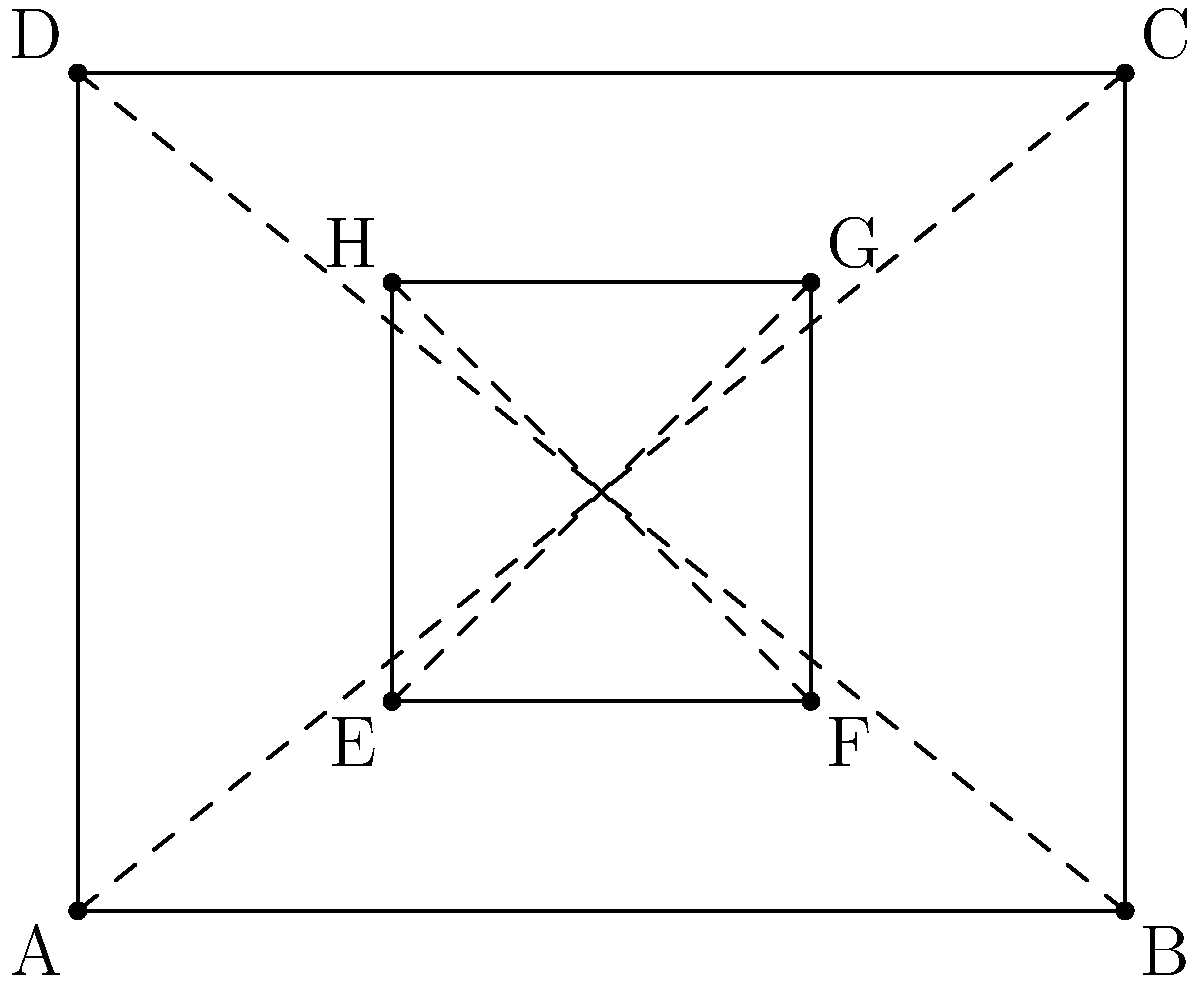In this simple architectural sketch of a room with a window, which perspective technique is being demonstrated by the dashed lines connecting opposite corners? To answer this question, let's analyze the sketch step-by-step:

1. The outer rectangle (ABCD) represents the room's walls.
2. The inner rectangle (EFGH) represents the window.
3. There are dashed lines connecting opposite corners of both the room and the window.

These dashed lines are demonstrating a fundamental principle in perspective drawing:

4. The lines AC and BD intersect at a point that would be on the horizon line (not shown in this sketch).
5. Similarly, the lines EG and FH also intersect at a point on the same horizon line.
6. This point of intersection is known as the vanishing point.

The technique being demonstrated here is one-point perspective. In one-point perspective:

7. All lines that are perpendicular to the viewer's line of sight converge at a single vanishing point on the horizon line.
8. This creates the illusion of depth and three-dimensionality on a two-dimensional surface.

One-point perspective is often used in architectural drawings and interior scenes where the viewer is looking straight at a wall or façade.
Answer: One-point perspective 